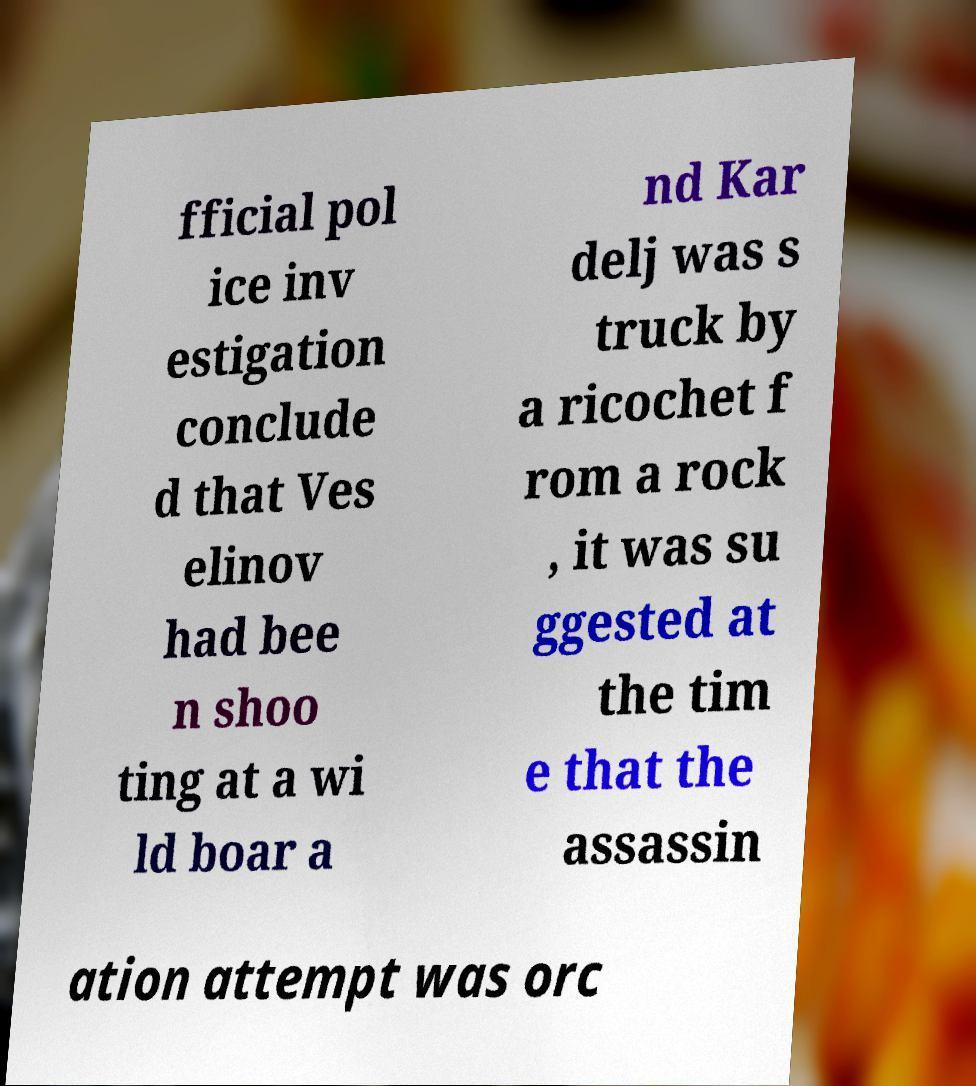Could you assist in decoding the text presented in this image and type it out clearly? fficial pol ice inv estigation conclude d that Ves elinov had bee n shoo ting at a wi ld boar a nd Kar delj was s truck by a ricochet f rom a rock , it was su ggested at the tim e that the assassin ation attempt was orc 